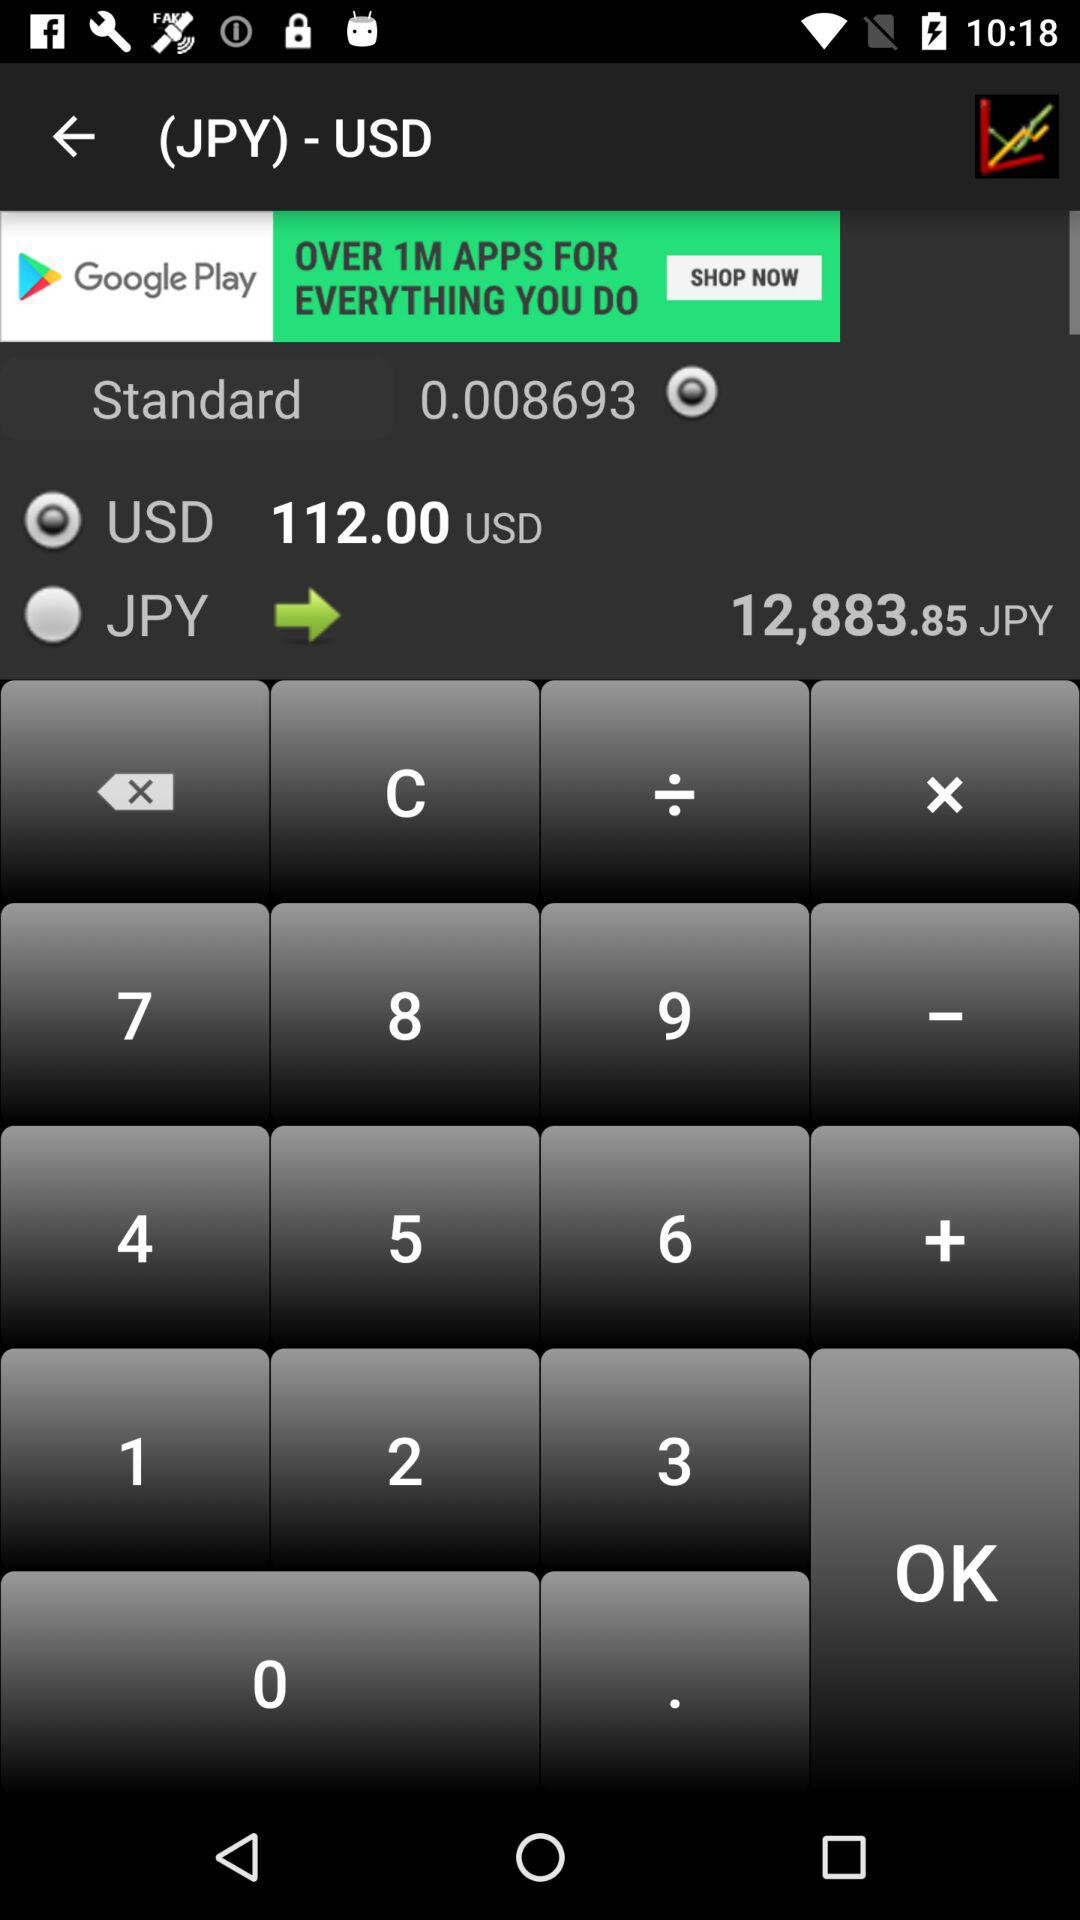Which option was selected?
When the provided information is insufficient, respond with <no answer>. <no answer> 